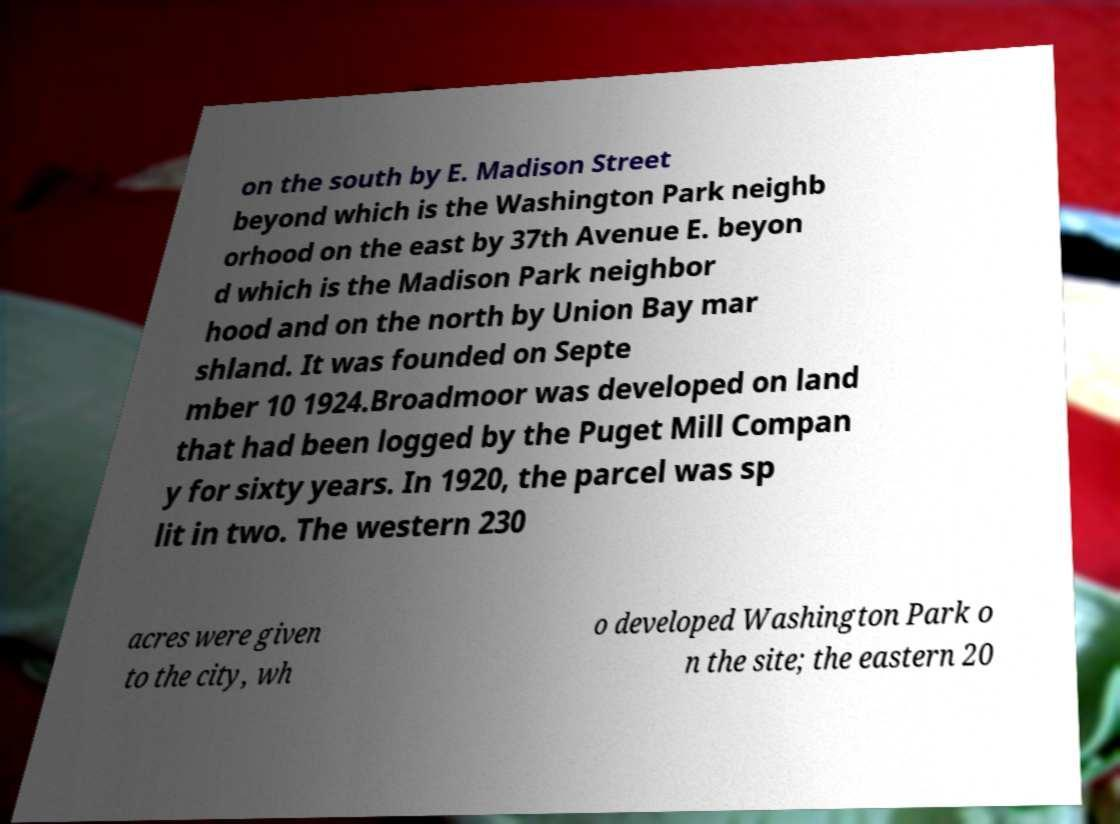Could you assist in decoding the text presented in this image and type it out clearly? on the south by E. Madison Street beyond which is the Washington Park neighb orhood on the east by 37th Avenue E. beyon d which is the Madison Park neighbor hood and on the north by Union Bay mar shland. It was founded on Septe mber 10 1924.Broadmoor was developed on land that had been logged by the Puget Mill Compan y for sixty years. In 1920, the parcel was sp lit in two. The western 230 acres were given to the city, wh o developed Washington Park o n the site; the eastern 20 